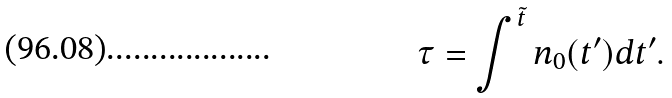Convert formula to latex. <formula><loc_0><loc_0><loc_500><loc_500>\tau = \int ^ { \tilde { t } } n _ { 0 } ( t ^ { \prime } ) d t ^ { \prime } .</formula> 